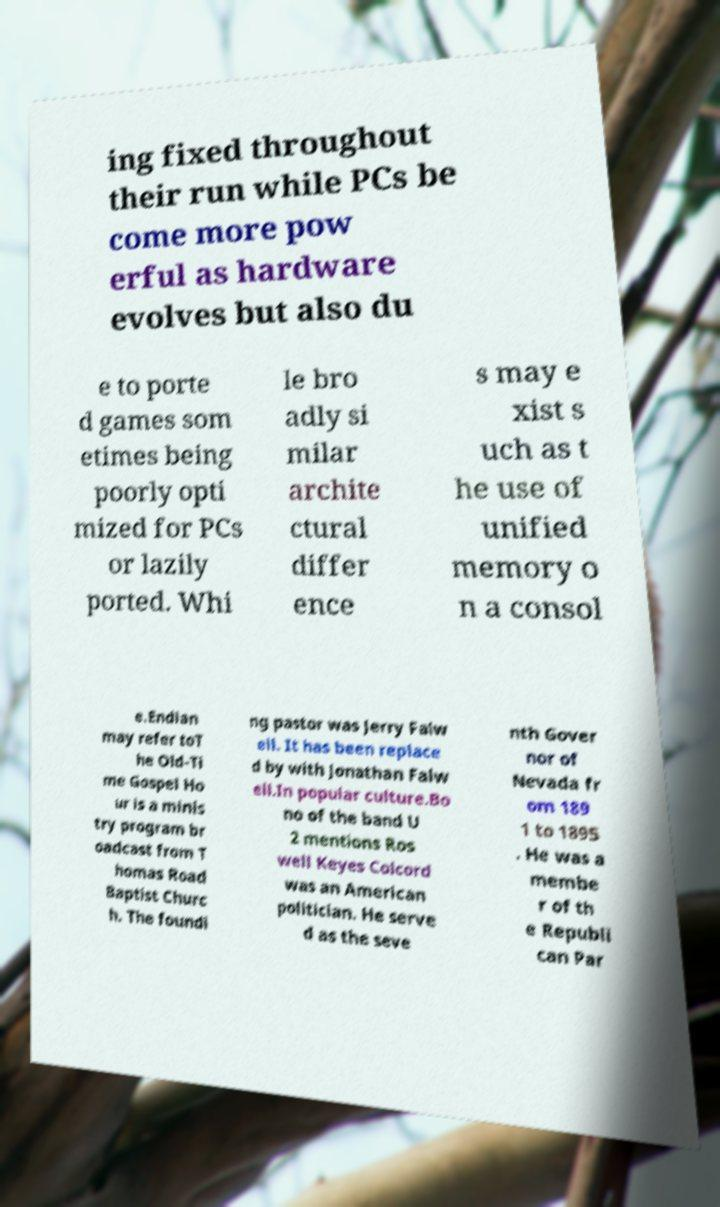For documentation purposes, I need the text within this image transcribed. Could you provide that? ing fixed throughout their run while PCs be come more pow erful as hardware evolves but also du e to porte d games som etimes being poorly opti mized for PCs or lazily ported. Whi le bro adly si milar archite ctural differ ence s may e xist s uch as t he use of unified memory o n a consol e.Endian may refer toT he Old-Ti me Gospel Ho ur is a minis try program br oadcast from T homas Road Baptist Churc h. The foundi ng pastor was Jerry Falw ell. It has been replace d by with Jonathan Falw ell.In popular culture.Bo no of the band U 2 mentions Ros well Keyes Colcord was an American politician. He serve d as the seve nth Gover nor of Nevada fr om 189 1 to 1895 . He was a membe r of th e Republi can Par 